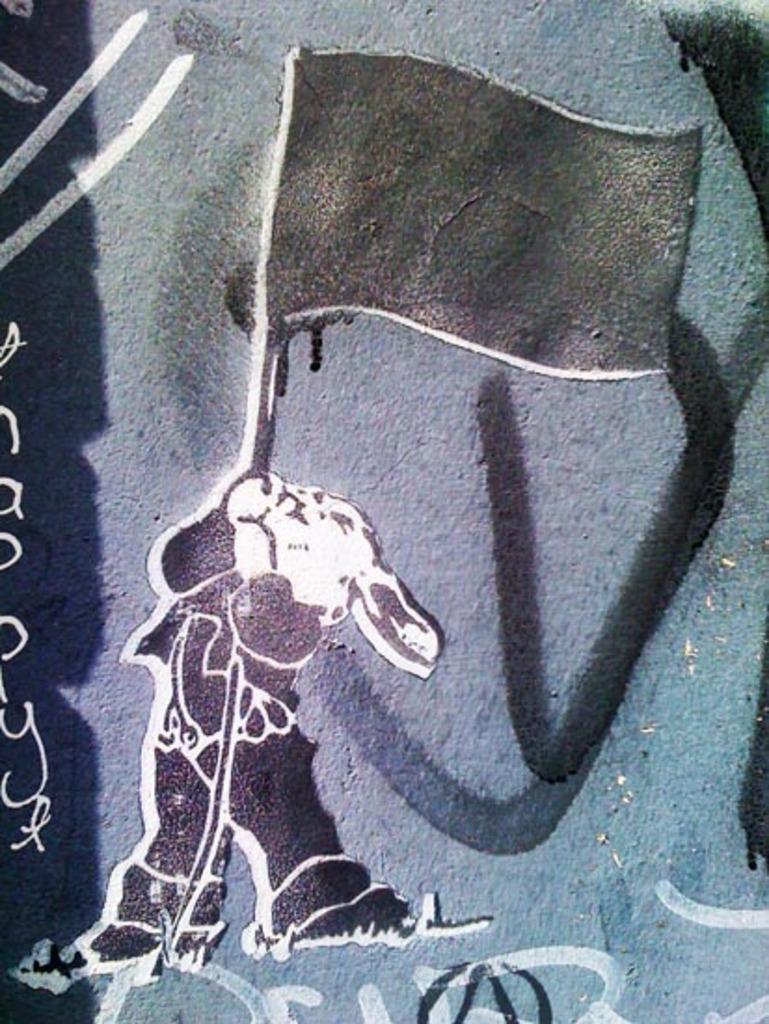How would you summarize this image in a sentence or two? In this image I can see a painting on a rock. In this painting a rabbit is holding a flag. 